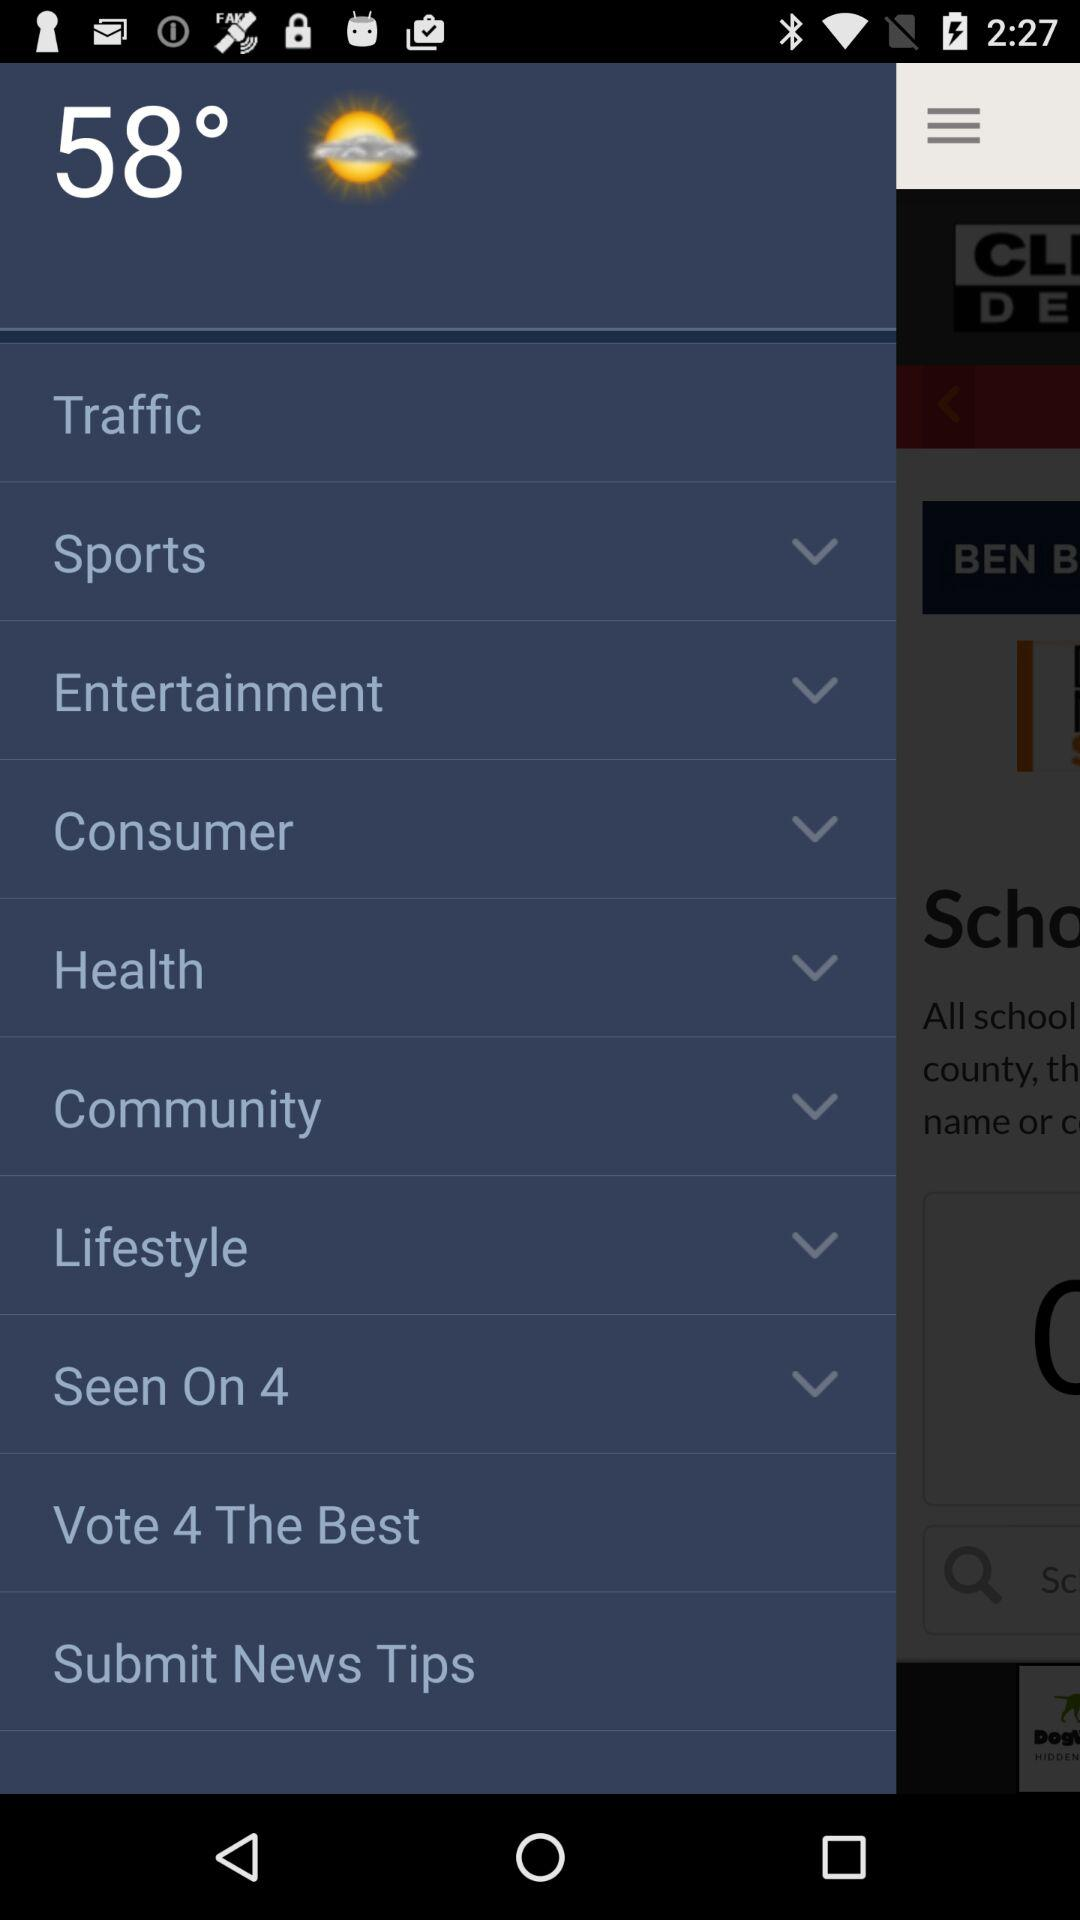What's the current weather? The current weather is partly sunny. 